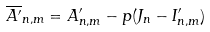<formula> <loc_0><loc_0><loc_500><loc_500>\overline { A ^ { \prime } } _ { n , m } = A ^ { \prime } _ { n , m } - p ( J _ { n } - I ^ { \prime } _ { n , m } )</formula> 